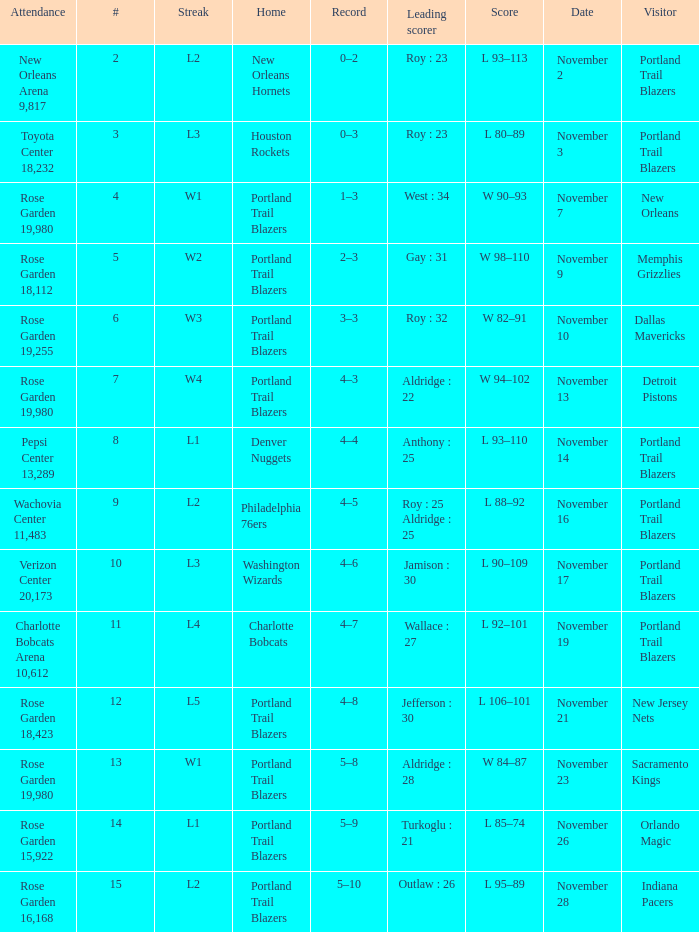What is the total number of date where visitor is new jersey nets 1.0. 